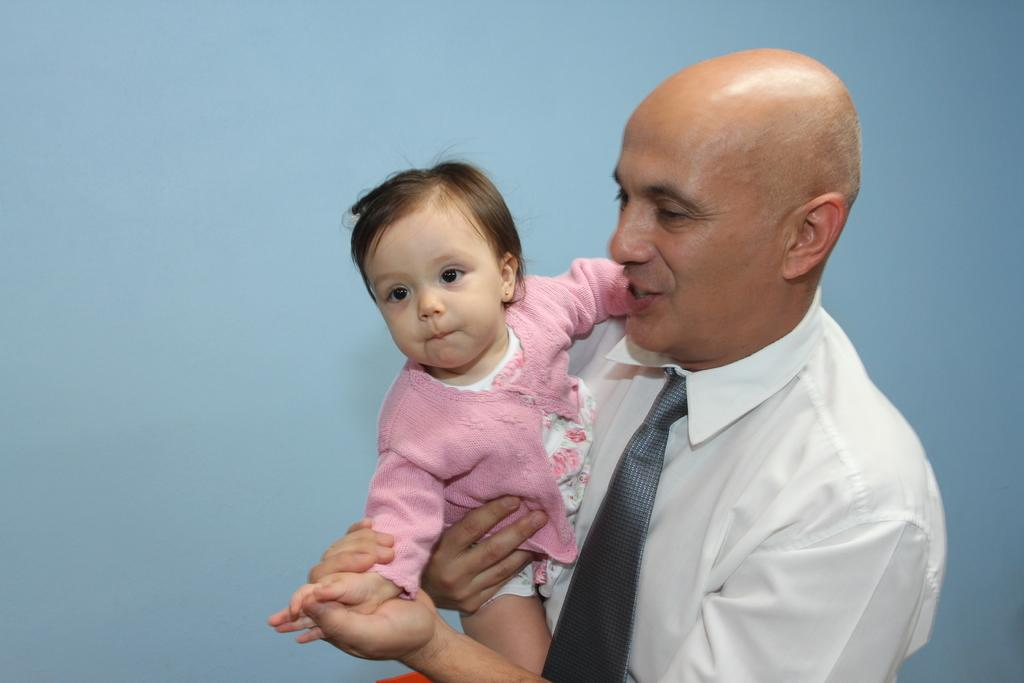What is the main subject of the image? There is a person in the image. What is the person doing in the image? The person is holding a baby. Where is the baby located in relation to the person? The baby is in the person's arms. What is the person's facial expression in the image? The person is smiling. What type of connection is visible between the person and the bomb in the image? There is no bomb present in the image, so there is no connection between the person and a bomb. 